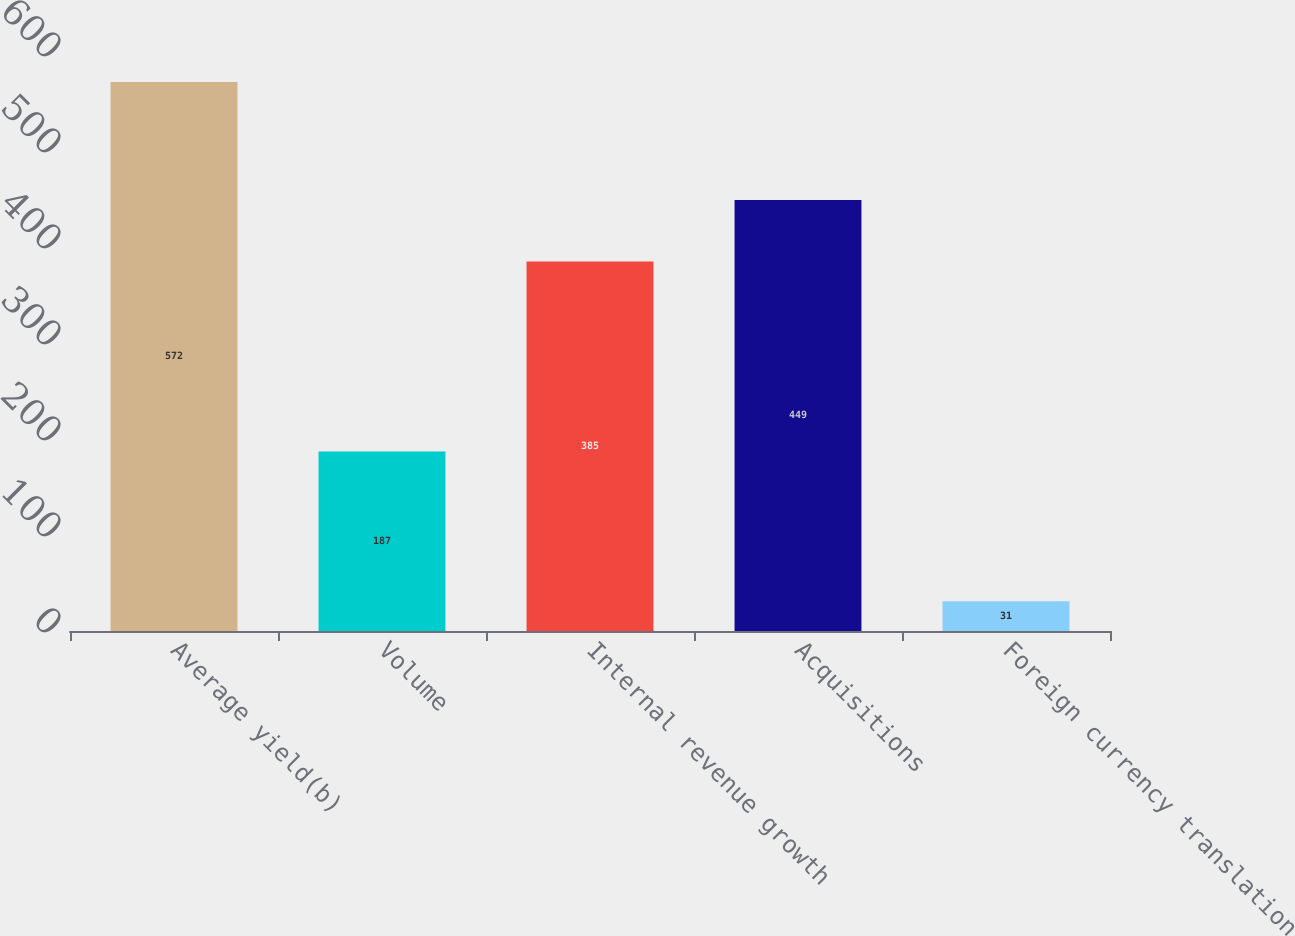<chart> <loc_0><loc_0><loc_500><loc_500><bar_chart><fcel>Average yield(b)<fcel>Volume<fcel>Internal revenue growth<fcel>Acquisitions<fcel>Foreign currency translation<nl><fcel>572<fcel>187<fcel>385<fcel>449<fcel>31<nl></chart> 